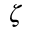<formula> <loc_0><loc_0><loc_500><loc_500>\zeta</formula> 